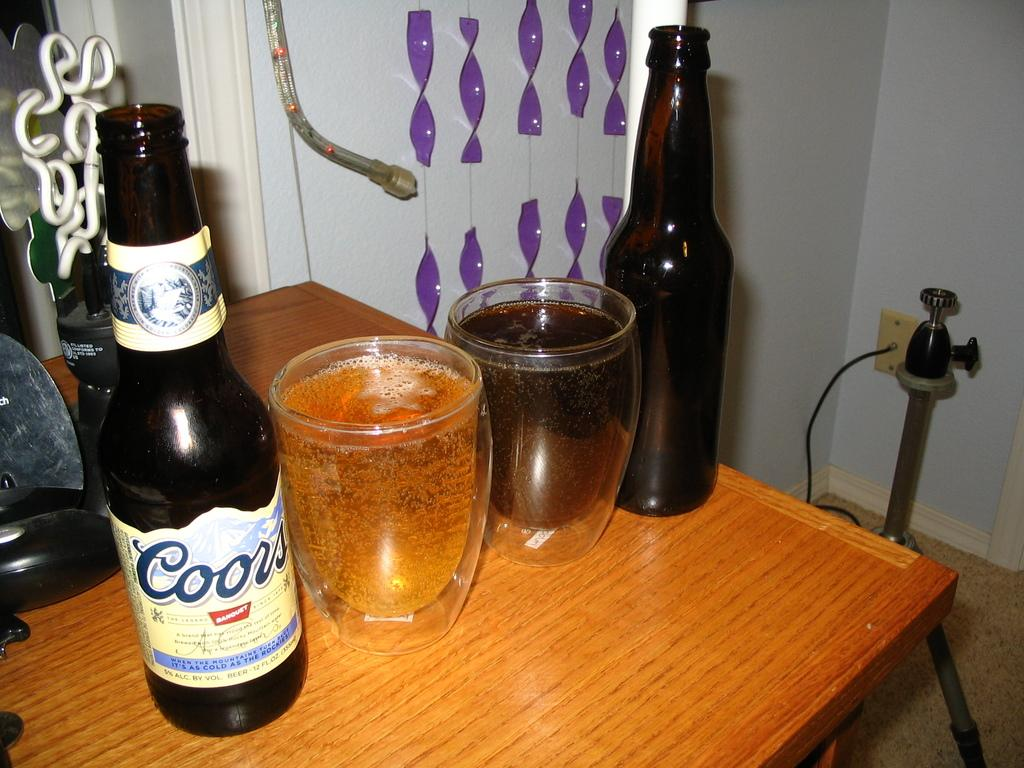<image>
Give a short and clear explanation of the subsequent image. A bottle of Coors sits next to a glass on a wooden table. 